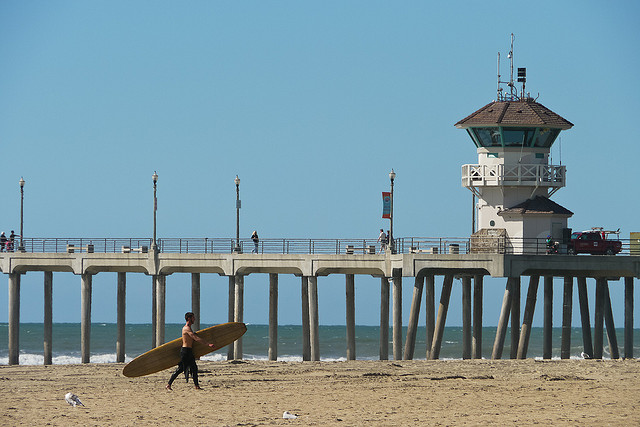<image>How many birds are on the beach? I don't know how many birds are on the beach. The number could vary. How many birds are on the beach? I don't know how many birds are on the beach. It could be 4, 1, 2 or 3. 